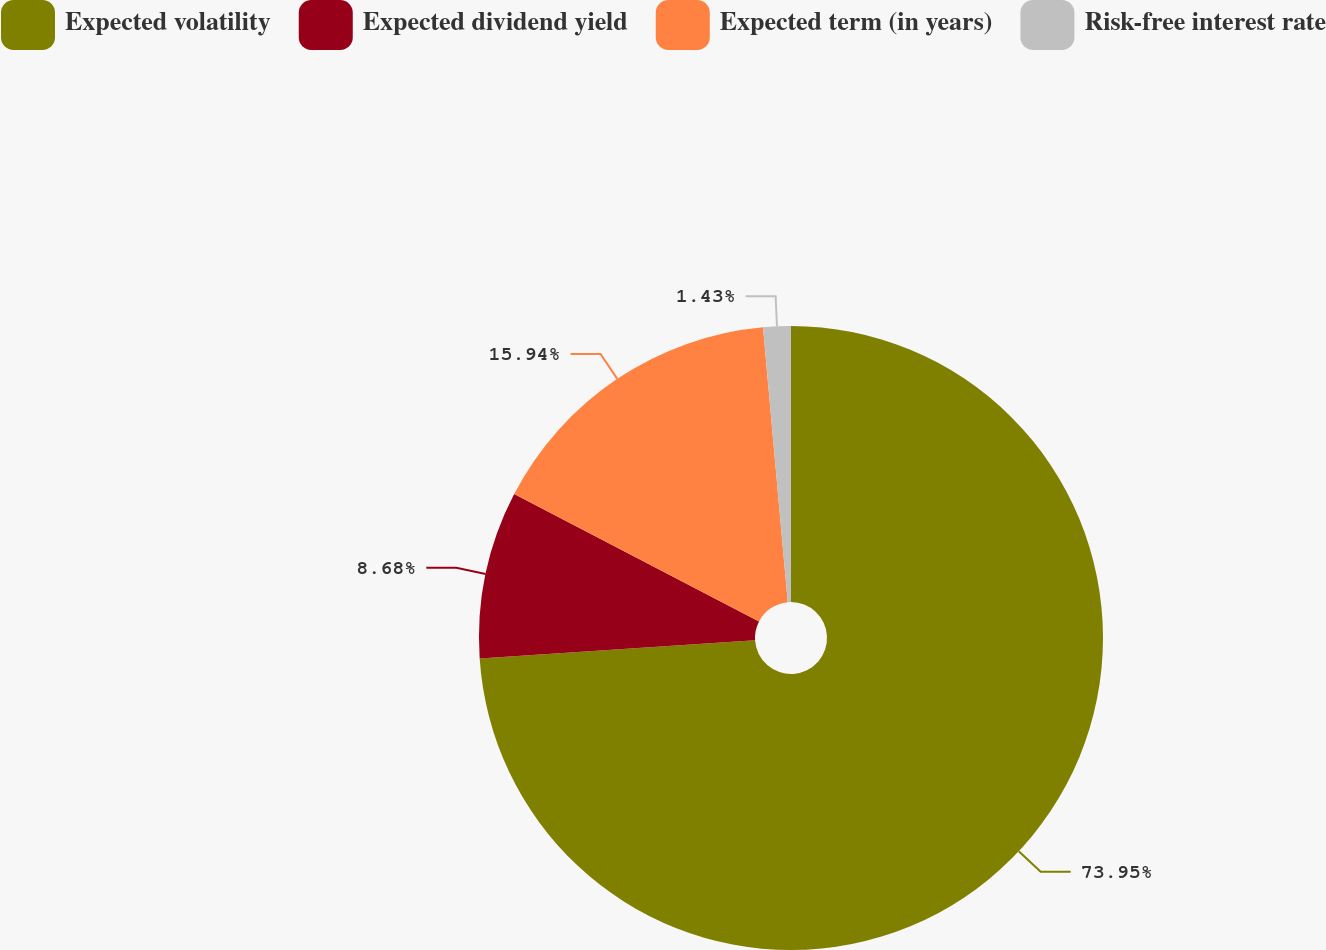Convert chart. <chart><loc_0><loc_0><loc_500><loc_500><pie_chart><fcel>Expected volatility<fcel>Expected dividend yield<fcel>Expected term (in years)<fcel>Risk-free interest rate<nl><fcel>73.95%<fcel>8.68%<fcel>15.94%<fcel>1.43%<nl></chart> 